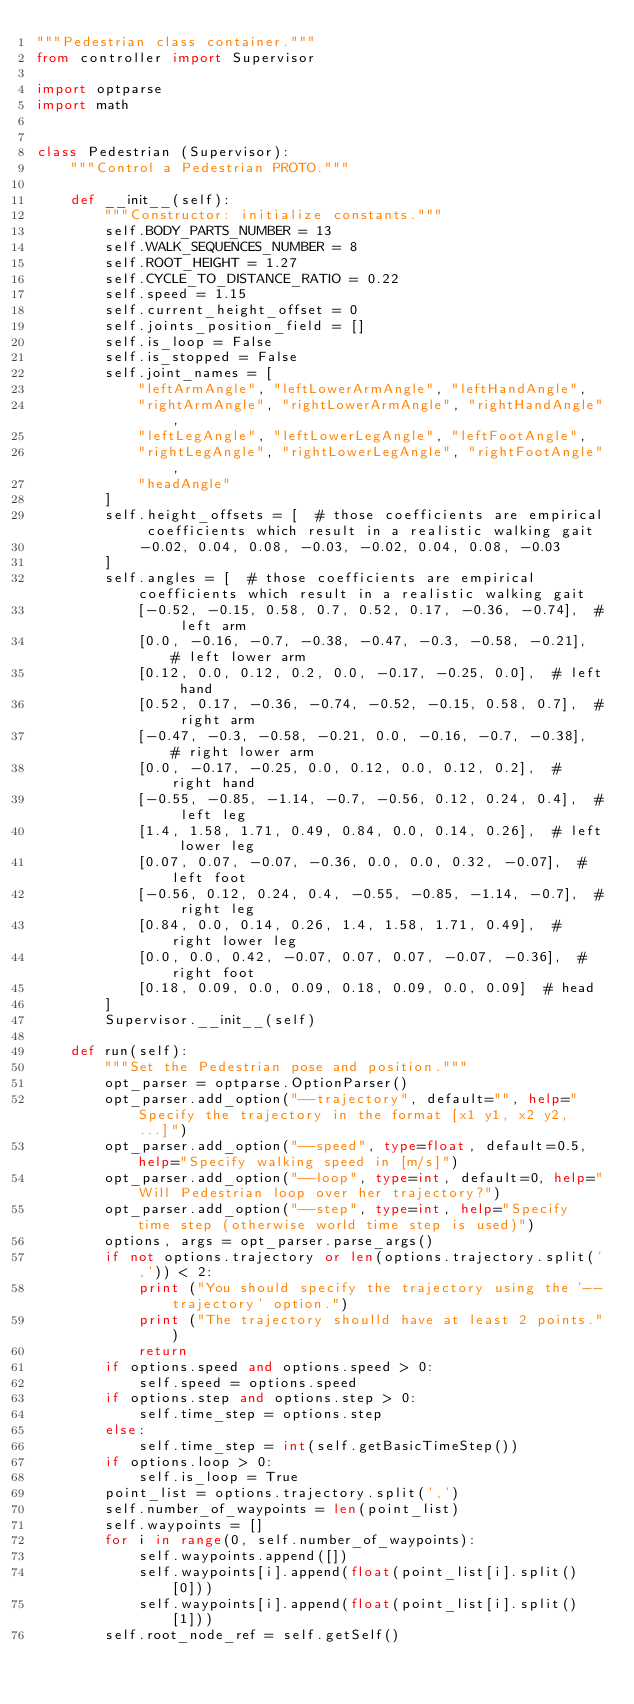<code> <loc_0><loc_0><loc_500><loc_500><_Python_>"""Pedestrian class container."""
from controller import Supervisor

import optparse
import math


class Pedestrian (Supervisor):
    """Control a Pedestrian PROTO."""

    def __init__(self):
        """Constructor: initialize constants."""
        self.BODY_PARTS_NUMBER = 13
        self.WALK_SEQUENCES_NUMBER = 8
        self.ROOT_HEIGHT = 1.27
        self.CYCLE_TO_DISTANCE_RATIO = 0.22
        self.speed = 1.15
        self.current_height_offset = 0
        self.joints_position_field = []
        self.is_loop = False
        self.is_stopped = False
        self.joint_names = [
            "leftArmAngle", "leftLowerArmAngle", "leftHandAngle",
            "rightArmAngle", "rightLowerArmAngle", "rightHandAngle",
            "leftLegAngle", "leftLowerLegAngle", "leftFootAngle",
            "rightLegAngle", "rightLowerLegAngle", "rightFootAngle",
            "headAngle"
        ]
        self.height_offsets = [  # those coefficients are empirical coefficients which result in a realistic walking gait
            -0.02, 0.04, 0.08, -0.03, -0.02, 0.04, 0.08, -0.03
        ]
        self.angles = [  # those coefficients are empirical coefficients which result in a realistic walking gait
            [-0.52, -0.15, 0.58, 0.7, 0.52, 0.17, -0.36, -0.74],  # left arm
            [0.0, -0.16, -0.7, -0.38, -0.47, -0.3, -0.58, -0.21],  # left lower arm
            [0.12, 0.0, 0.12, 0.2, 0.0, -0.17, -0.25, 0.0],  # left hand
            [0.52, 0.17, -0.36, -0.74, -0.52, -0.15, 0.58, 0.7],  # right arm
            [-0.47, -0.3, -0.58, -0.21, 0.0, -0.16, -0.7, -0.38],  # right lower arm
            [0.0, -0.17, -0.25, 0.0, 0.12, 0.0, 0.12, 0.2],  # right hand
            [-0.55, -0.85, -1.14, -0.7, -0.56, 0.12, 0.24, 0.4],  # left leg
            [1.4, 1.58, 1.71, 0.49, 0.84, 0.0, 0.14, 0.26],  # left lower leg
            [0.07, 0.07, -0.07, -0.36, 0.0, 0.0, 0.32, -0.07],  # left foot
            [-0.56, 0.12, 0.24, 0.4, -0.55, -0.85, -1.14, -0.7],  # right leg
            [0.84, 0.0, 0.14, 0.26, 1.4, 1.58, 1.71, 0.49],  # right lower leg
            [0.0, 0.0, 0.42, -0.07, 0.07, 0.07, -0.07, -0.36],  # right foot
            [0.18, 0.09, 0.0, 0.09, 0.18, 0.09, 0.0, 0.09]  # head
        ]
        Supervisor.__init__(self)

    def run(self):
        """Set the Pedestrian pose and position."""
        opt_parser = optparse.OptionParser()
        opt_parser.add_option("--trajectory", default="", help="Specify the trajectory in the format [x1 y1, x2 y2, ...]")
        opt_parser.add_option("--speed", type=float, default=0.5, help="Specify walking speed in [m/s]")
        opt_parser.add_option("--loop", type=int, default=0, help="Will Pedestrian loop over her trajectory?")
        opt_parser.add_option("--step", type=int, help="Specify time step (otherwise world time step is used)")
        options, args = opt_parser.parse_args()
        if not options.trajectory or len(options.trajectory.split(',')) < 2:
            print ("You should specify the trajectory using the '--trajectory' option.")
            print ("The trajectory shoulld have at least 2 points.")
            return
        if options.speed and options.speed > 0:
            self.speed = options.speed
        if options.step and options.step > 0:
            self.time_step = options.step
        else:
            self.time_step = int(self.getBasicTimeStep())
        if options.loop > 0:
            self.is_loop = True
        point_list = options.trajectory.split(',')
        self.number_of_waypoints = len(point_list)
        self.waypoints = []
        for i in range(0, self.number_of_waypoints):
            self.waypoints.append([])
            self.waypoints[i].append(float(point_list[i].split()[0]))
            self.waypoints[i].append(float(point_list[i].split()[1]))
        self.root_node_ref = self.getSelf()</code> 